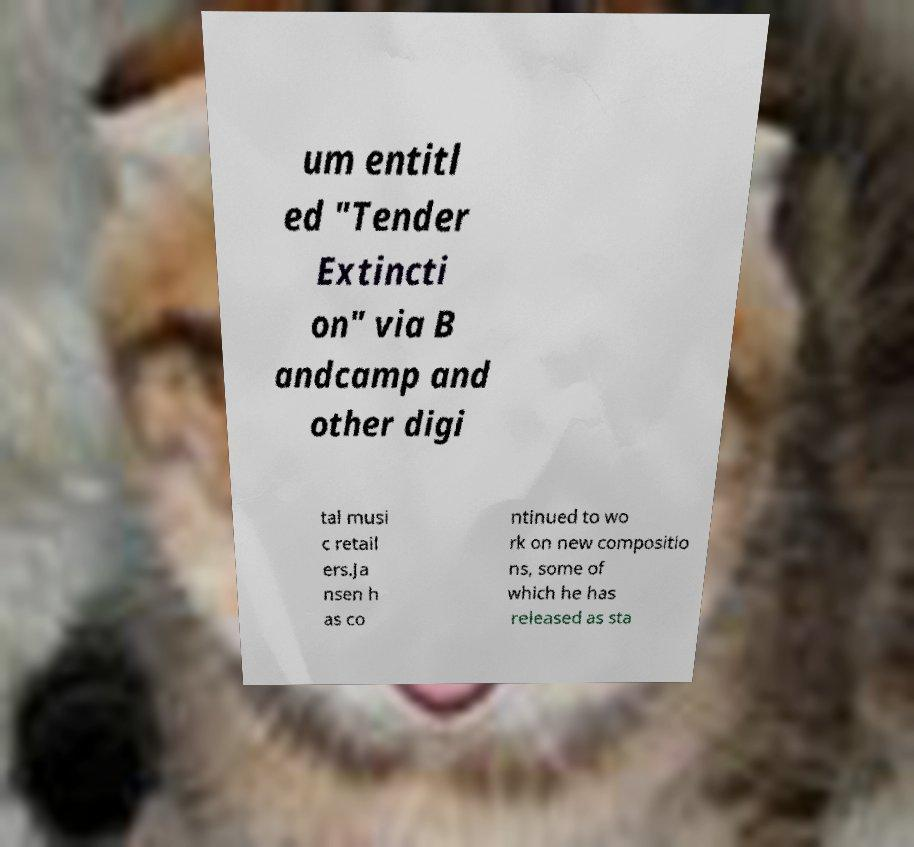Can you read and provide the text displayed in the image?This photo seems to have some interesting text. Can you extract and type it out for me? um entitl ed "Tender Extincti on" via B andcamp and other digi tal musi c retail ers.Ja nsen h as co ntinued to wo rk on new compositio ns, some of which he has released as sta 